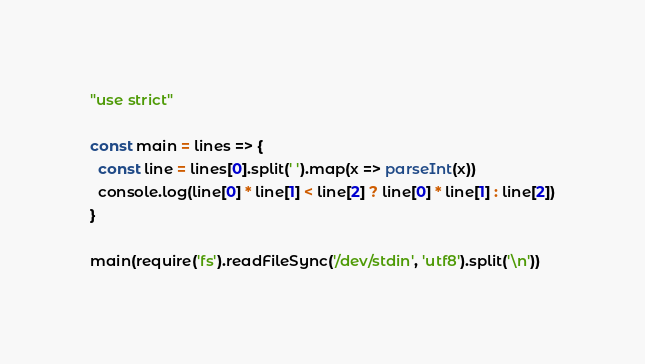<code> <loc_0><loc_0><loc_500><loc_500><_JavaScript_>"use strict"

const main = lines => {
  const line = lines[0].split(' ').map(x => parseInt(x))
  console.log(line[0] * line[1] < line[2] ? line[0] * line[1] : line[2])
}

main(require('fs').readFileSync('/dev/stdin', 'utf8').split('\n'))</code> 